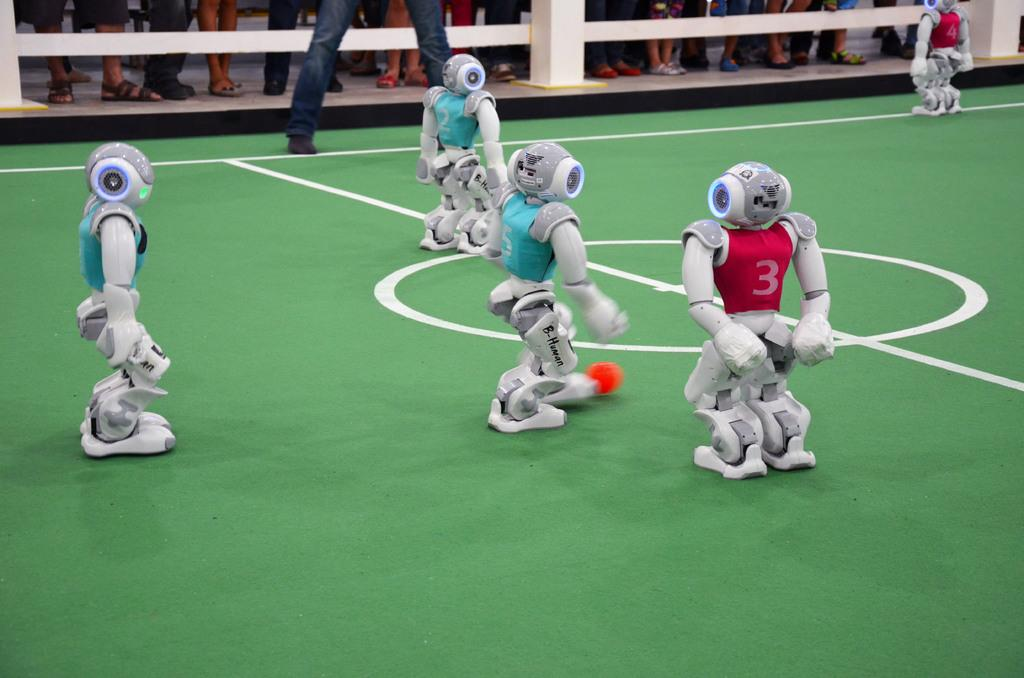<image>
Write a terse but informative summary of the picture. two robot soccer team with blue and red jerseys with different numbers like 3 and 4 